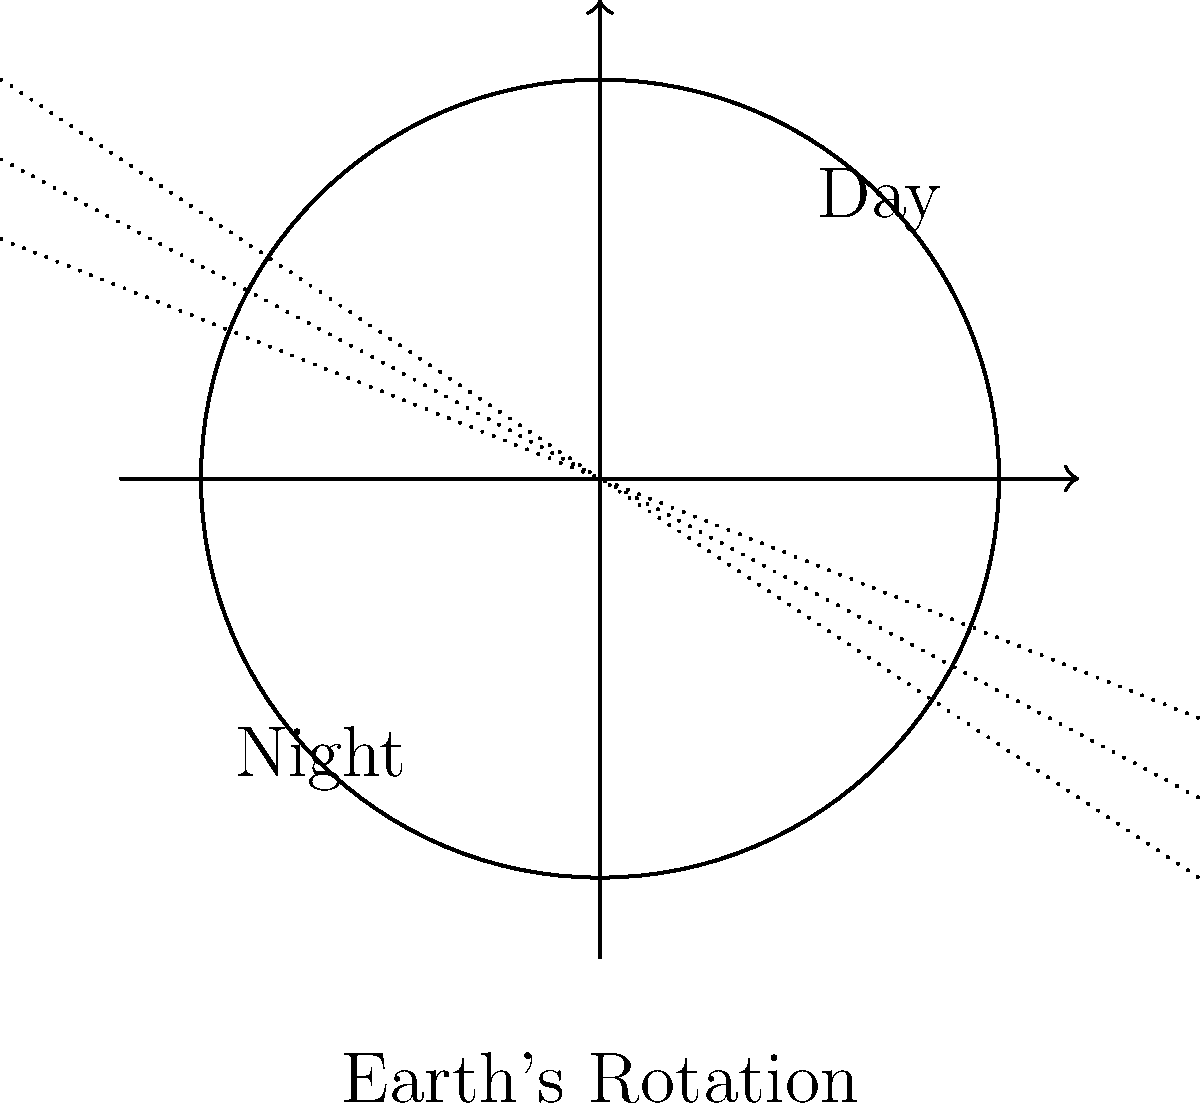Imagine you're explaining to your fellow farmers how the Earth's rotation affects daylight hours during different seasons. Using the diagram, how would you describe the relationship between Earth's tilt and the length of day in Scotland compared to a place like Rio de Janeiro during summer? 1. Earth's axis is tilted at approximately 23.5 degrees relative to its orbital plane.

2. This tilt causes the Northern and Southern Hemispheres to receive different amounts of sunlight throughout the year as Earth orbits the Sun.

3. During Northern Hemisphere summer (June to August):
   a. Scotland, being further north, is tilted more towards the Sun.
   b. Rio de Janeiro, being closer to the equator, experiences less variation.

4. The tilt results in:
   a. Longer days in Scotland during summer, with the Sun appearing higher in the sky.
   b. Shorter nights in Scotland during this period.
   c. More consistent day/night cycles in Rio de Janeiro year-round.

5. The opposite occurs during Northern Hemisphere winter (December to February):
   a. Scotland experiences shorter days and longer nights.
   b. Rio de Janeiro still maintains relatively consistent day/night cycles.

6. This difference is due to:
   a. Scotland's higher latitude (about 56°N)
   b. Rio de Janeiro's proximity to the equator (about 23°S)

7. The diagram shows:
   a. Earth's rotation axis
   b. Day and night sides
   c. Incoming solar radiation (dotted lines)

8. As Earth rotates, locations move from the night side to the day side, but the duration in each varies based on latitude and season.
Answer: Scotland has longer summer days than Rio due to its higher latitude and Earth's axial tilt. 